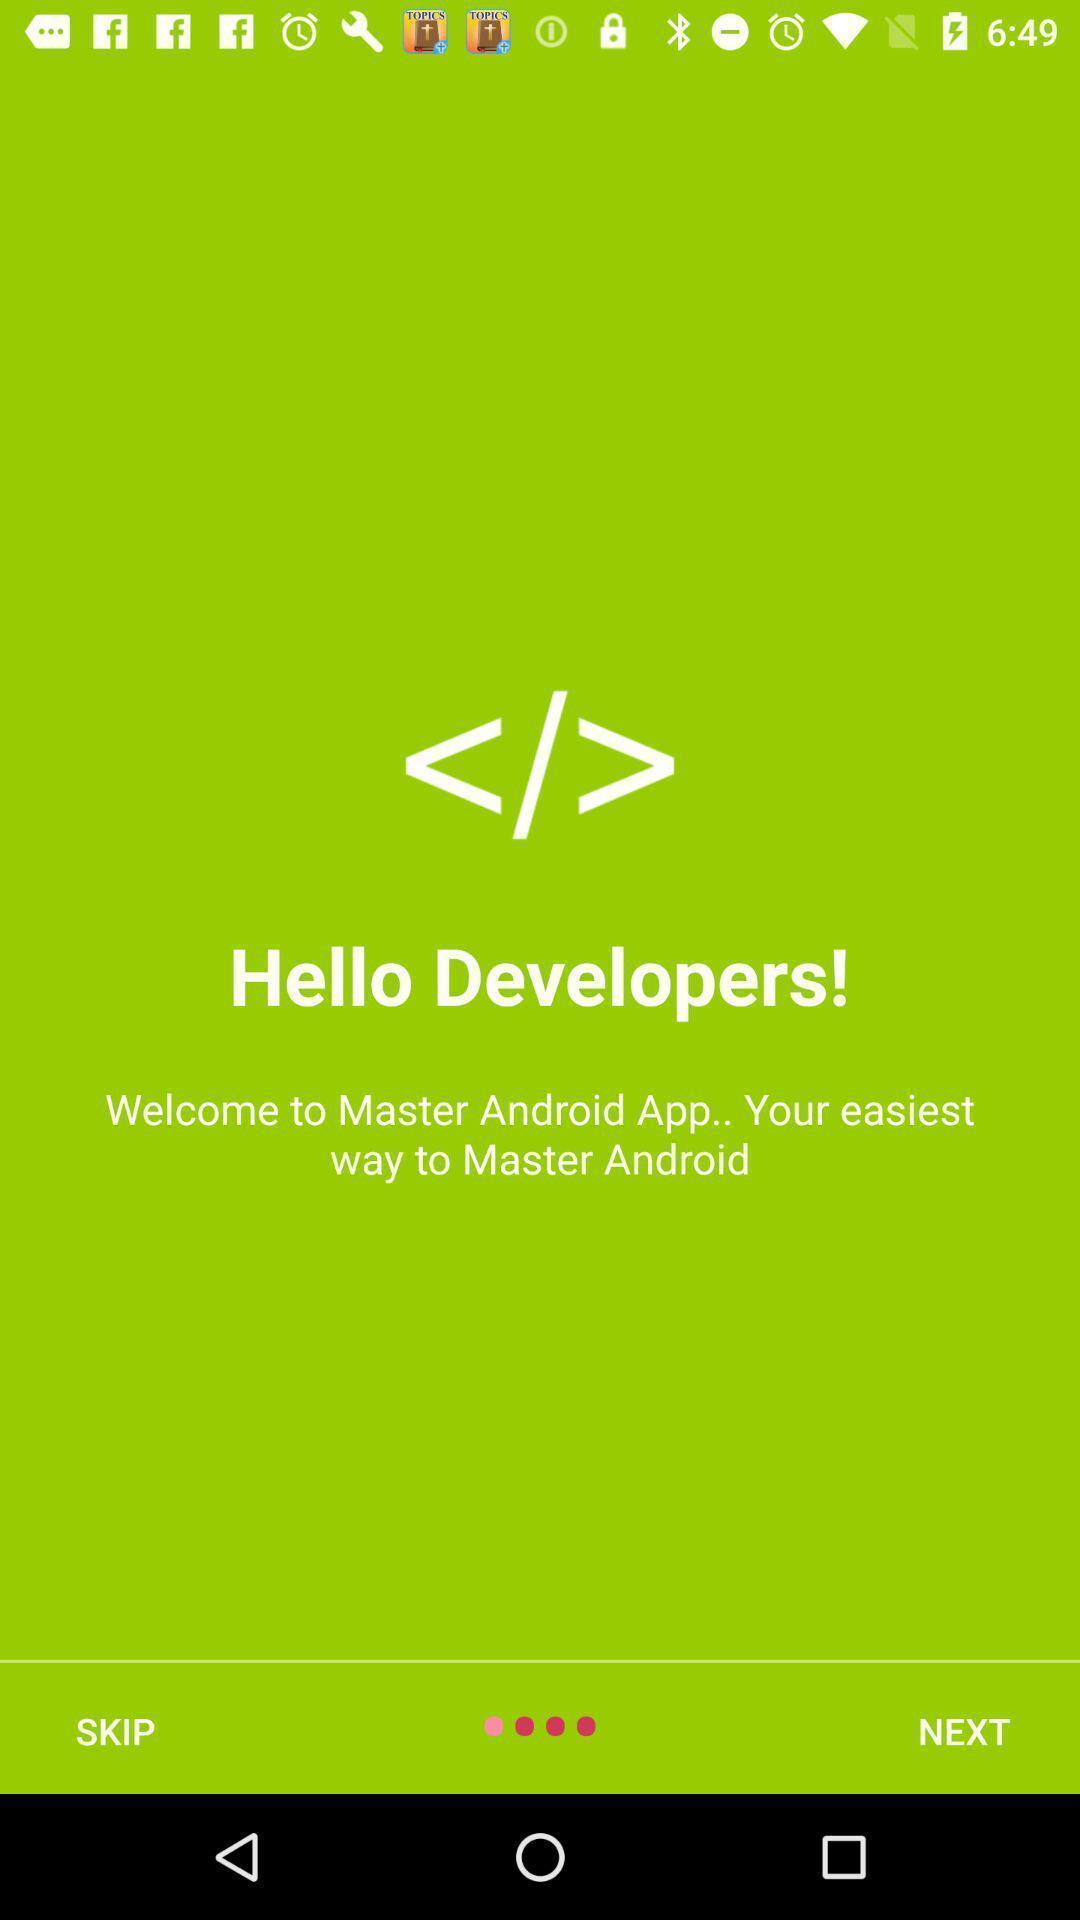Summarize the information in this screenshot. Welcome page with skip and next options. 